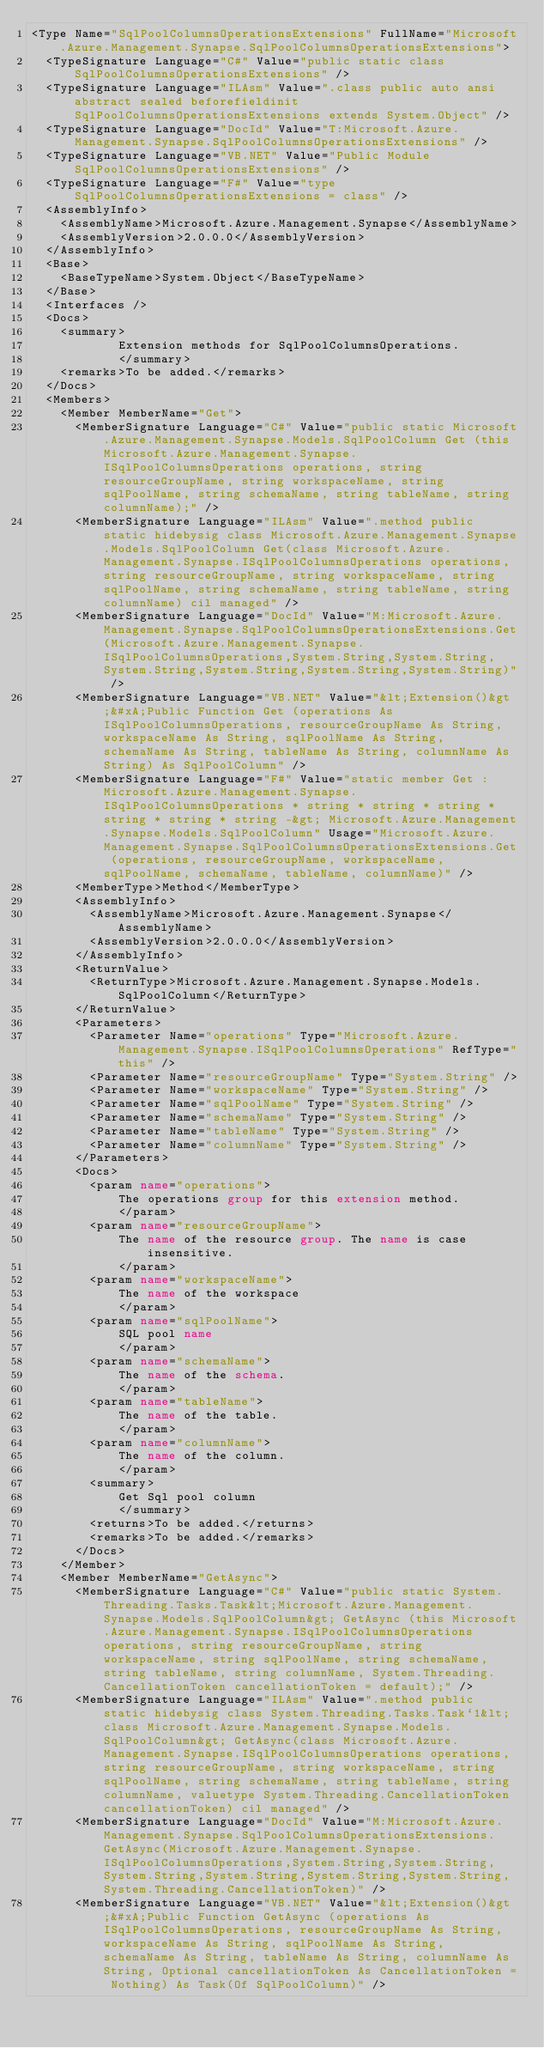<code> <loc_0><loc_0><loc_500><loc_500><_XML_><Type Name="SqlPoolColumnsOperationsExtensions" FullName="Microsoft.Azure.Management.Synapse.SqlPoolColumnsOperationsExtensions">
  <TypeSignature Language="C#" Value="public static class SqlPoolColumnsOperationsExtensions" />
  <TypeSignature Language="ILAsm" Value=".class public auto ansi abstract sealed beforefieldinit SqlPoolColumnsOperationsExtensions extends System.Object" />
  <TypeSignature Language="DocId" Value="T:Microsoft.Azure.Management.Synapse.SqlPoolColumnsOperationsExtensions" />
  <TypeSignature Language="VB.NET" Value="Public Module SqlPoolColumnsOperationsExtensions" />
  <TypeSignature Language="F#" Value="type SqlPoolColumnsOperationsExtensions = class" />
  <AssemblyInfo>
    <AssemblyName>Microsoft.Azure.Management.Synapse</AssemblyName>
    <AssemblyVersion>2.0.0.0</AssemblyVersion>
  </AssemblyInfo>
  <Base>
    <BaseTypeName>System.Object</BaseTypeName>
  </Base>
  <Interfaces />
  <Docs>
    <summary>
            Extension methods for SqlPoolColumnsOperations.
            </summary>
    <remarks>To be added.</remarks>
  </Docs>
  <Members>
    <Member MemberName="Get">
      <MemberSignature Language="C#" Value="public static Microsoft.Azure.Management.Synapse.Models.SqlPoolColumn Get (this Microsoft.Azure.Management.Synapse.ISqlPoolColumnsOperations operations, string resourceGroupName, string workspaceName, string sqlPoolName, string schemaName, string tableName, string columnName);" />
      <MemberSignature Language="ILAsm" Value=".method public static hidebysig class Microsoft.Azure.Management.Synapse.Models.SqlPoolColumn Get(class Microsoft.Azure.Management.Synapse.ISqlPoolColumnsOperations operations, string resourceGroupName, string workspaceName, string sqlPoolName, string schemaName, string tableName, string columnName) cil managed" />
      <MemberSignature Language="DocId" Value="M:Microsoft.Azure.Management.Synapse.SqlPoolColumnsOperationsExtensions.Get(Microsoft.Azure.Management.Synapse.ISqlPoolColumnsOperations,System.String,System.String,System.String,System.String,System.String,System.String)" />
      <MemberSignature Language="VB.NET" Value="&lt;Extension()&gt;&#xA;Public Function Get (operations As ISqlPoolColumnsOperations, resourceGroupName As String, workspaceName As String, sqlPoolName As String, schemaName As String, tableName As String, columnName As String) As SqlPoolColumn" />
      <MemberSignature Language="F#" Value="static member Get : Microsoft.Azure.Management.Synapse.ISqlPoolColumnsOperations * string * string * string * string * string * string -&gt; Microsoft.Azure.Management.Synapse.Models.SqlPoolColumn" Usage="Microsoft.Azure.Management.Synapse.SqlPoolColumnsOperationsExtensions.Get (operations, resourceGroupName, workspaceName, sqlPoolName, schemaName, tableName, columnName)" />
      <MemberType>Method</MemberType>
      <AssemblyInfo>
        <AssemblyName>Microsoft.Azure.Management.Synapse</AssemblyName>
        <AssemblyVersion>2.0.0.0</AssemblyVersion>
      </AssemblyInfo>
      <ReturnValue>
        <ReturnType>Microsoft.Azure.Management.Synapse.Models.SqlPoolColumn</ReturnType>
      </ReturnValue>
      <Parameters>
        <Parameter Name="operations" Type="Microsoft.Azure.Management.Synapse.ISqlPoolColumnsOperations" RefType="this" />
        <Parameter Name="resourceGroupName" Type="System.String" />
        <Parameter Name="workspaceName" Type="System.String" />
        <Parameter Name="sqlPoolName" Type="System.String" />
        <Parameter Name="schemaName" Type="System.String" />
        <Parameter Name="tableName" Type="System.String" />
        <Parameter Name="columnName" Type="System.String" />
      </Parameters>
      <Docs>
        <param name="operations">
            The operations group for this extension method.
            </param>
        <param name="resourceGroupName">
            The name of the resource group. The name is case insensitive.
            </param>
        <param name="workspaceName">
            The name of the workspace
            </param>
        <param name="sqlPoolName">
            SQL pool name
            </param>
        <param name="schemaName">
            The name of the schema.
            </param>
        <param name="tableName">
            The name of the table.
            </param>
        <param name="columnName">
            The name of the column.
            </param>
        <summary>
            Get Sql pool column
            </summary>
        <returns>To be added.</returns>
        <remarks>To be added.</remarks>
      </Docs>
    </Member>
    <Member MemberName="GetAsync">
      <MemberSignature Language="C#" Value="public static System.Threading.Tasks.Task&lt;Microsoft.Azure.Management.Synapse.Models.SqlPoolColumn&gt; GetAsync (this Microsoft.Azure.Management.Synapse.ISqlPoolColumnsOperations operations, string resourceGroupName, string workspaceName, string sqlPoolName, string schemaName, string tableName, string columnName, System.Threading.CancellationToken cancellationToken = default);" />
      <MemberSignature Language="ILAsm" Value=".method public static hidebysig class System.Threading.Tasks.Task`1&lt;class Microsoft.Azure.Management.Synapse.Models.SqlPoolColumn&gt; GetAsync(class Microsoft.Azure.Management.Synapse.ISqlPoolColumnsOperations operations, string resourceGroupName, string workspaceName, string sqlPoolName, string schemaName, string tableName, string columnName, valuetype System.Threading.CancellationToken cancellationToken) cil managed" />
      <MemberSignature Language="DocId" Value="M:Microsoft.Azure.Management.Synapse.SqlPoolColumnsOperationsExtensions.GetAsync(Microsoft.Azure.Management.Synapse.ISqlPoolColumnsOperations,System.String,System.String,System.String,System.String,System.String,System.String,System.Threading.CancellationToken)" />
      <MemberSignature Language="VB.NET" Value="&lt;Extension()&gt;&#xA;Public Function GetAsync (operations As ISqlPoolColumnsOperations, resourceGroupName As String, workspaceName As String, sqlPoolName As String, schemaName As String, tableName As String, columnName As String, Optional cancellationToken As CancellationToken = Nothing) As Task(Of SqlPoolColumn)" /></code> 